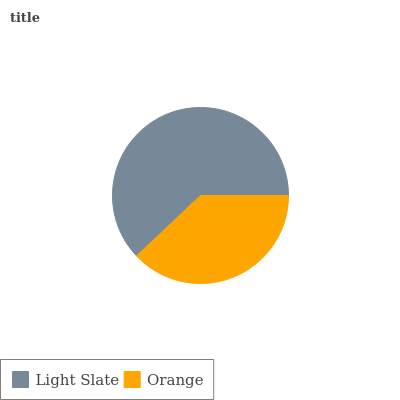Is Orange the minimum?
Answer yes or no. Yes. Is Light Slate the maximum?
Answer yes or no. Yes. Is Orange the maximum?
Answer yes or no. No. Is Light Slate greater than Orange?
Answer yes or no. Yes. Is Orange less than Light Slate?
Answer yes or no. Yes. Is Orange greater than Light Slate?
Answer yes or no. No. Is Light Slate less than Orange?
Answer yes or no. No. Is Light Slate the high median?
Answer yes or no. Yes. Is Orange the low median?
Answer yes or no. Yes. Is Orange the high median?
Answer yes or no. No. Is Light Slate the low median?
Answer yes or no. No. 